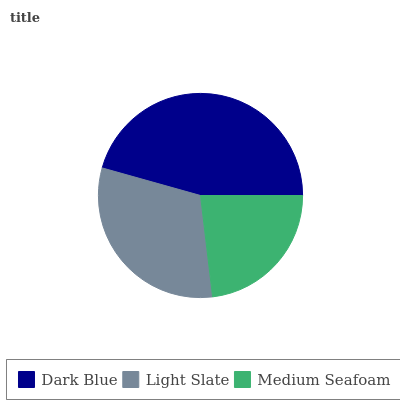Is Medium Seafoam the minimum?
Answer yes or no. Yes. Is Dark Blue the maximum?
Answer yes or no. Yes. Is Light Slate the minimum?
Answer yes or no. No. Is Light Slate the maximum?
Answer yes or no. No. Is Dark Blue greater than Light Slate?
Answer yes or no. Yes. Is Light Slate less than Dark Blue?
Answer yes or no. Yes. Is Light Slate greater than Dark Blue?
Answer yes or no. No. Is Dark Blue less than Light Slate?
Answer yes or no. No. Is Light Slate the high median?
Answer yes or no. Yes. Is Light Slate the low median?
Answer yes or no. Yes. Is Dark Blue the high median?
Answer yes or no. No. Is Dark Blue the low median?
Answer yes or no. No. 